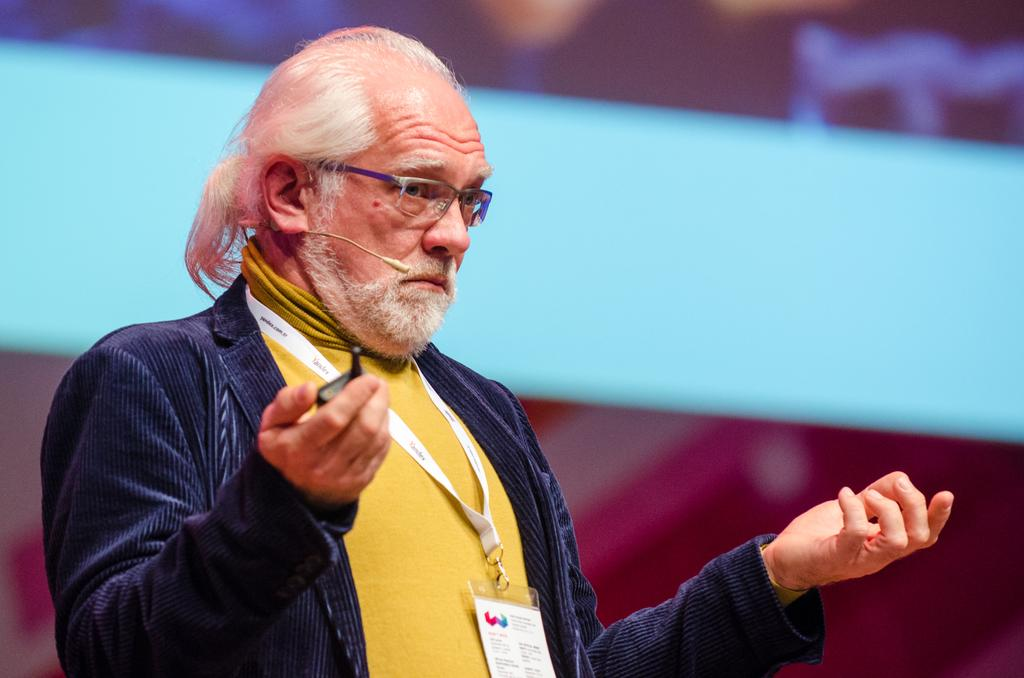What is the main subject in the image? There is a person standing in the image. What type of cheese is being served by the minister in the image? There is no minister or cheese present in the image; it only features a person standing. 